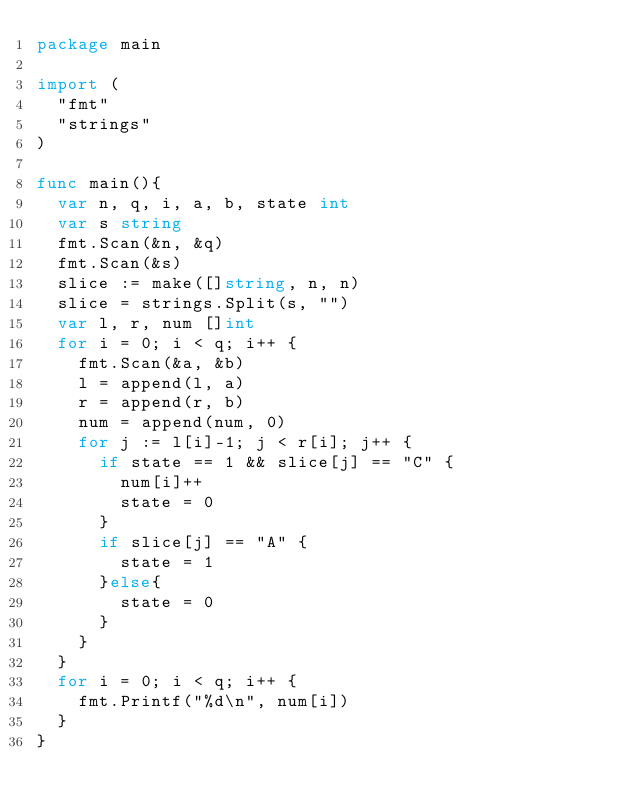<code> <loc_0><loc_0><loc_500><loc_500><_Go_>package main

import (
	"fmt"
	"strings"
)

func main(){
	var n, q, i, a, b, state int
	var s string
	fmt.Scan(&n, &q)
	fmt.Scan(&s)
	slice := make([]string, n, n)
	slice = strings.Split(s, "")
	var l, r, num []int
	for i = 0; i < q; i++ {
		fmt.Scan(&a, &b)
		l = append(l, a)
		r = append(r, b)
		num = append(num, 0)
		for j := l[i]-1; j < r[i]; j++ {
			if state == 1 && slice[j] == "C" {
				num[i]++
				state = 0
			}
			if slice[j] == "A" {
				state = 1
			}else{
				state = 0
			}
		}
	}
	for i = 0; i < q; i++ {
		fmt.Printf("%d\n", num[i])
	}
}</code> 